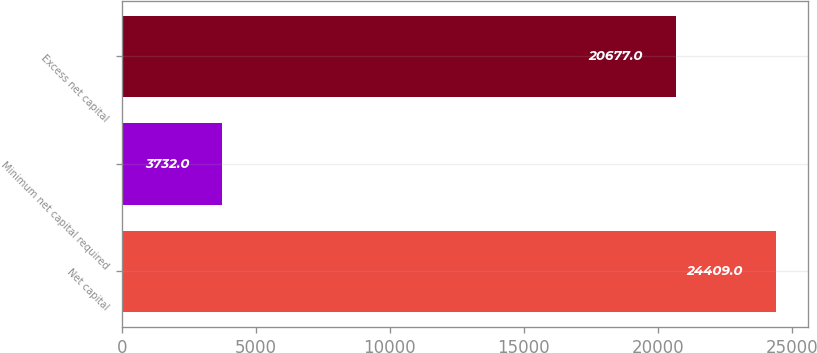Convert chart to OTSL. <chart><loc_0><loc_0><loc_500><loc_500><bar_chart><fcel>Net capital<fcel>Minimum net capital required<fcel>Excess net capital<nl><fcel>24409<fcel>3732<fcel>20677<nl></chart> 